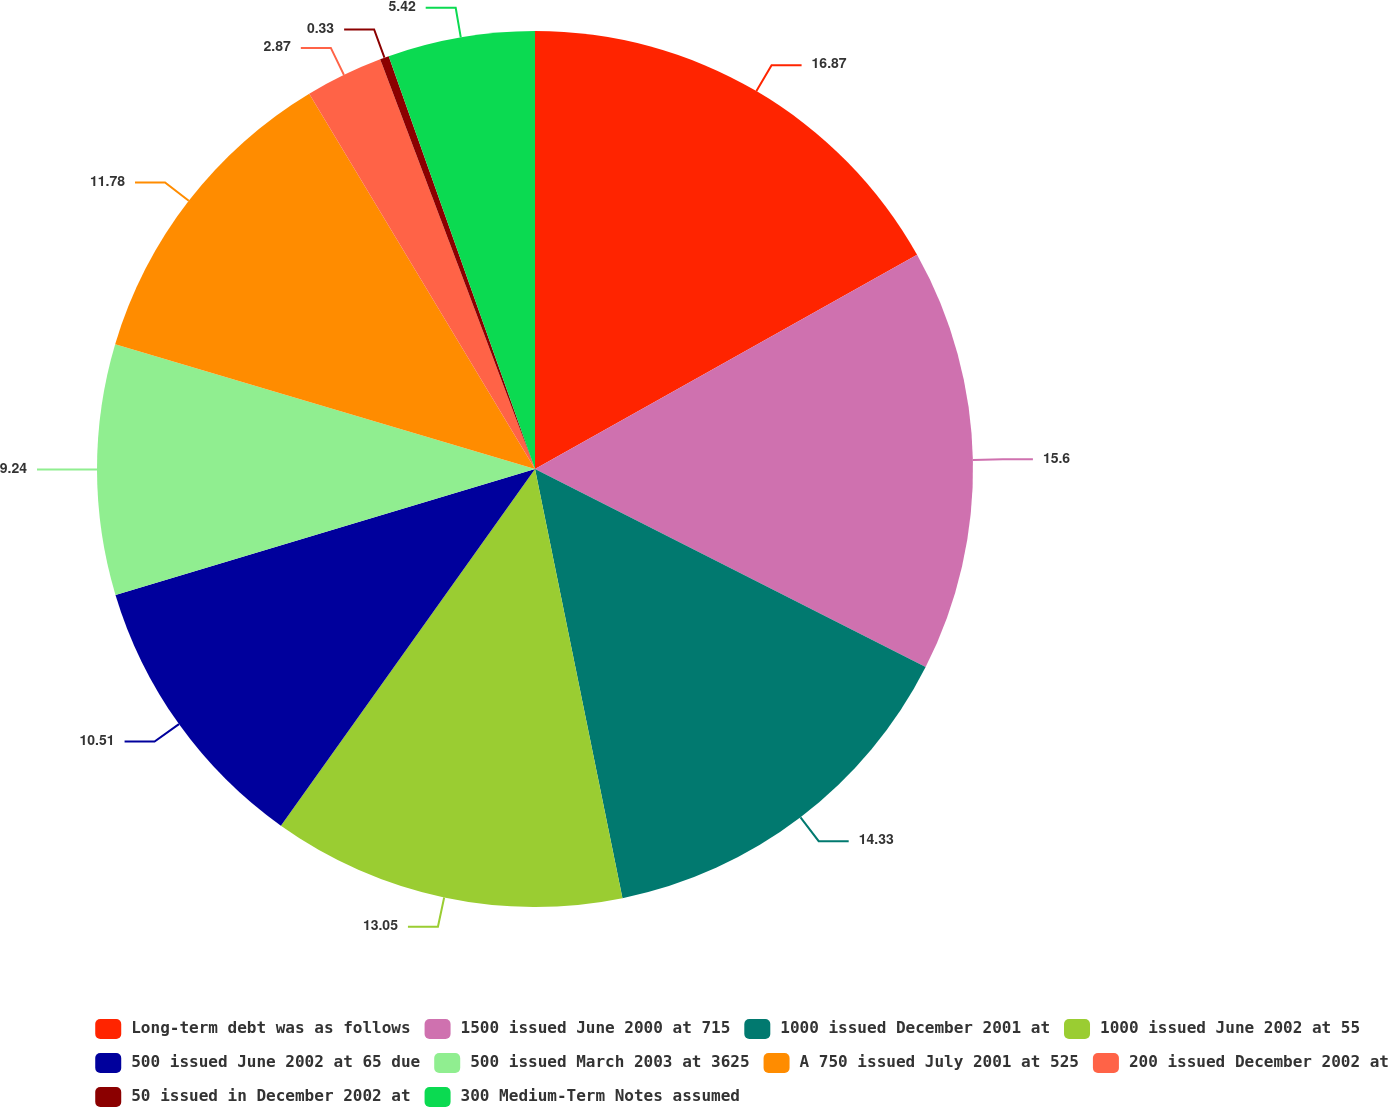<chart> <loc_0><loc_0><loc_500><loc_500><pie_chart><fcel>Long-term debt was as follows<fcel>1500 issued June 2000 at 715<fcel>1000 issued December 2001 at<fcel>1000 issued June 2002 at 55<fcel>500 issued June 2002 at 65 due<fcel>500 issued March 2003 at 3625<fcel>A 750 issued July 2001 at 525<fcel>200 issued December 2002 at<fcel>50 issued in December 2002 at<fcel>300 Medium-Term Notes assumed<nl><fcel>16.87%<fcel>15.6%<fcel>14.33%<fcel>13.05%<fcel>10.51%<fcel>9.24%<fcel>11.78%<fcel>2.87%<fcel>0.33%<fcel>5.42%<nl></chart> 